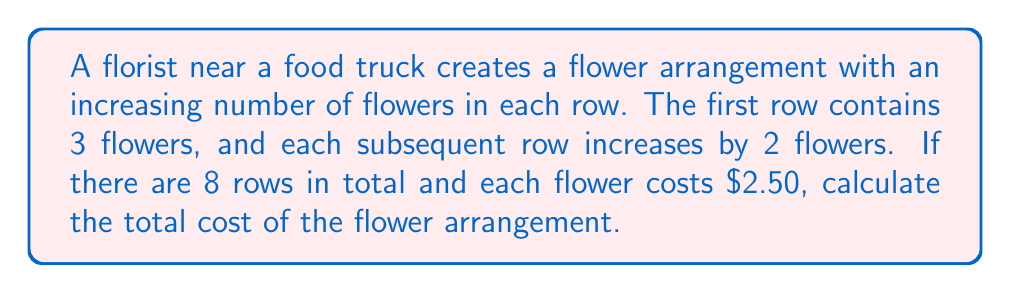Give your solution to this math problem. Let's approach this step-by-step using an arithmetic sequence:

1) First, we need to find the number of flowers in each row:
   - 1st row: 3 flowers
   - 2nd row: 5 flowers
   - 3rd row: 7 flowers
   ...and so on

2) This forms an arithmetic sequence with:
   - First term, $a_1 = 3$
   - Common difference, $d = 2$
   - Number of terms, $n = 8$ (as there are 8 rows)

3) To find the total number of flowers, we need to find the sum of this arithmetic sequence. We can use the formula:

   $$ S_n = \frac{n}{2}(a_1 + a_n) $$

   Where $a_n$ is the last term, which we can find using:
   $$ a_n = a_1 + (n-1)d $$

4) Let's calculate $a_n$:
   $$ a_8 = 3 + (8-1)2 = 3 + 14 = 17 $$

5) Now we can calculate the sum:
   $$ S_8 = \frac{8}{2}(3 + 17) = 4(20) = 80 $$

6) So, there are 80 flowers in total.

7) Each flower costs $2.50, so the total cost is:
   $$ 80 \times $2.50 = $200 $$

Therefore, the total cost of the flower arrangement is $200.
Answer: $200 